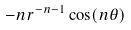<formula> <loc_0><loc_0><loc_500><loc_500>- n r ^ { - n - 1 } \cos ( n \theta )</formula> 